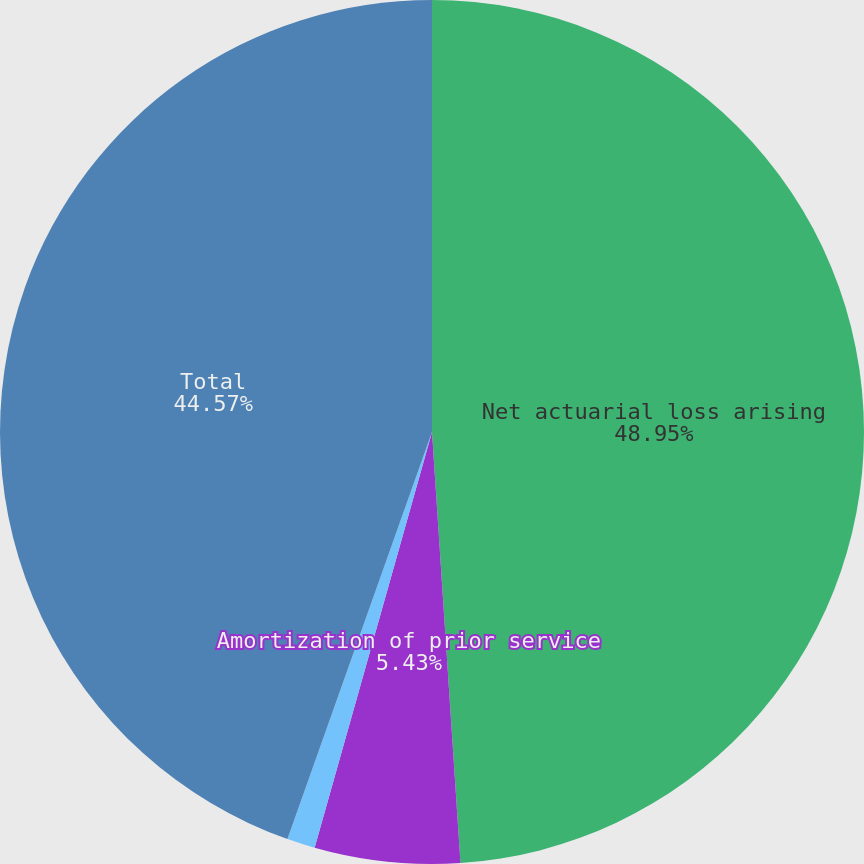<chart> <loc_0><loc_0><loc_500><loc_500><pie_chart><fcel>Net actuarial loss arising<fcel>Amortization of prior service<fcel>Amortization of actuarial<fcel>Total<nl><fcel>48.95%<fcel>5.43%<fcel>1.05%<fcel>44.57%<nl></chart> 